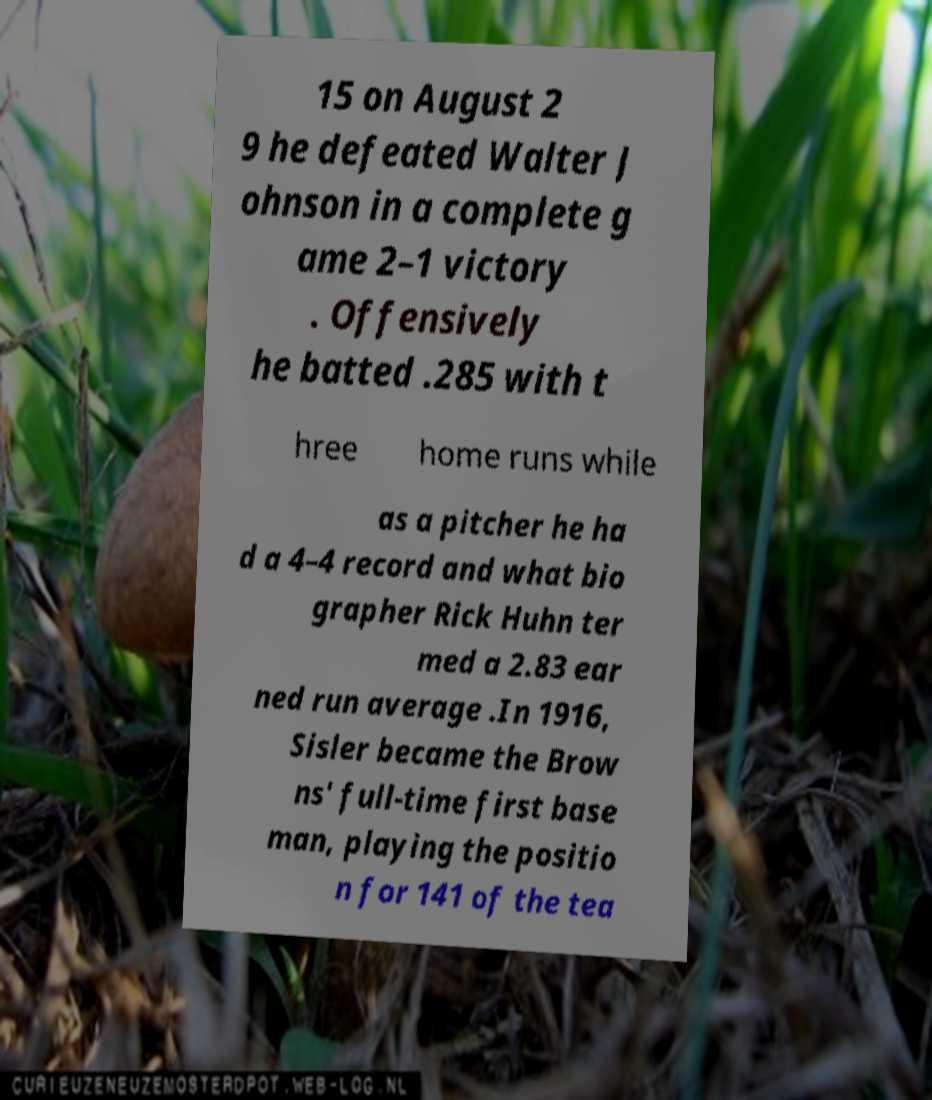Could you extract and type out the text from this image? 15 on August 2 9 he defeated Walter J ohnson in a complete g ame 2–1 victory . Offensively he batted .285 with t hree home runs while as a pitcher he ha d a 4–4 record and what bio grapher Rick Huhn ter med a 2.83 ear ned run average .In 1916, Sisler became the Brow ns' full-time first base man, playing the positio n for 141 of the tea 